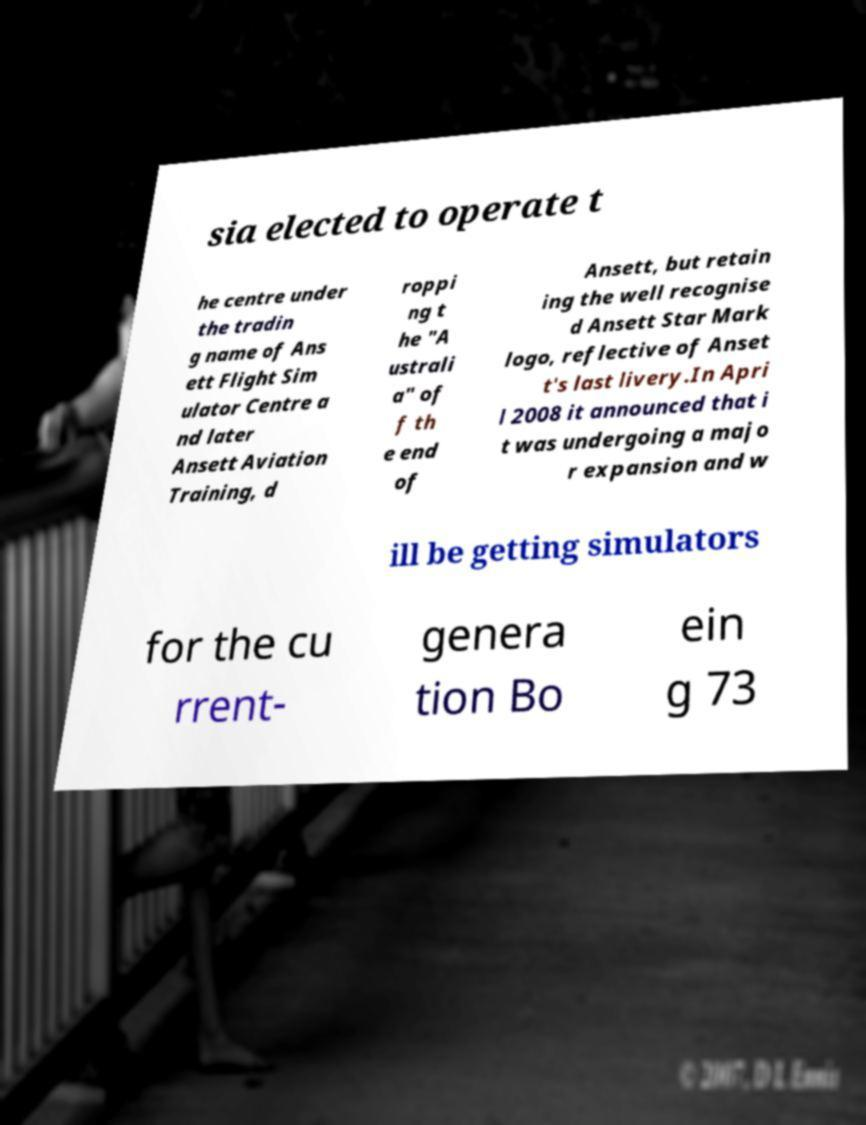There's text embedded in this image that I need extracted. Can you transcribe it verbatim? sia elected to operate t he centre under the tradin g name of Ans ett Flight Sim ulator Centre a nd later Ansett Aviation Training, d roppi ng t he "A ustrali a" of f th e end of Ansett, but retain ing the well recognise d Ansett Star Mark logo, reflective of Anset t's last livery.In Apri l 2008 it announced that i t was undergoing a majo r expansion and w ill be getting simulators for the cu rrent- genera tion Bo ein g 73 